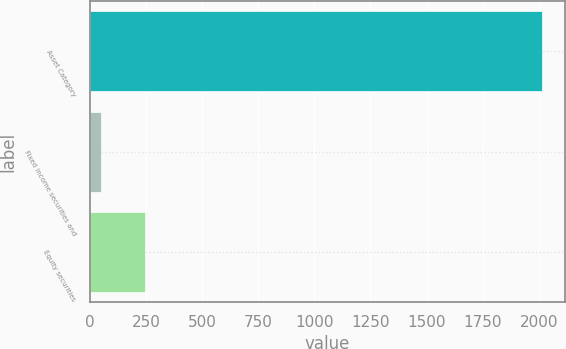Convert chart to OTSL. <chart><loc_0><loc_0><loc_500><loc_500><bar_chart><fcel>Asset Category<fcel>Fixed income securities and<fcel>Equity securities<nl><fcel>2015<fcel>50<fcel>246.5<nl></chart> 